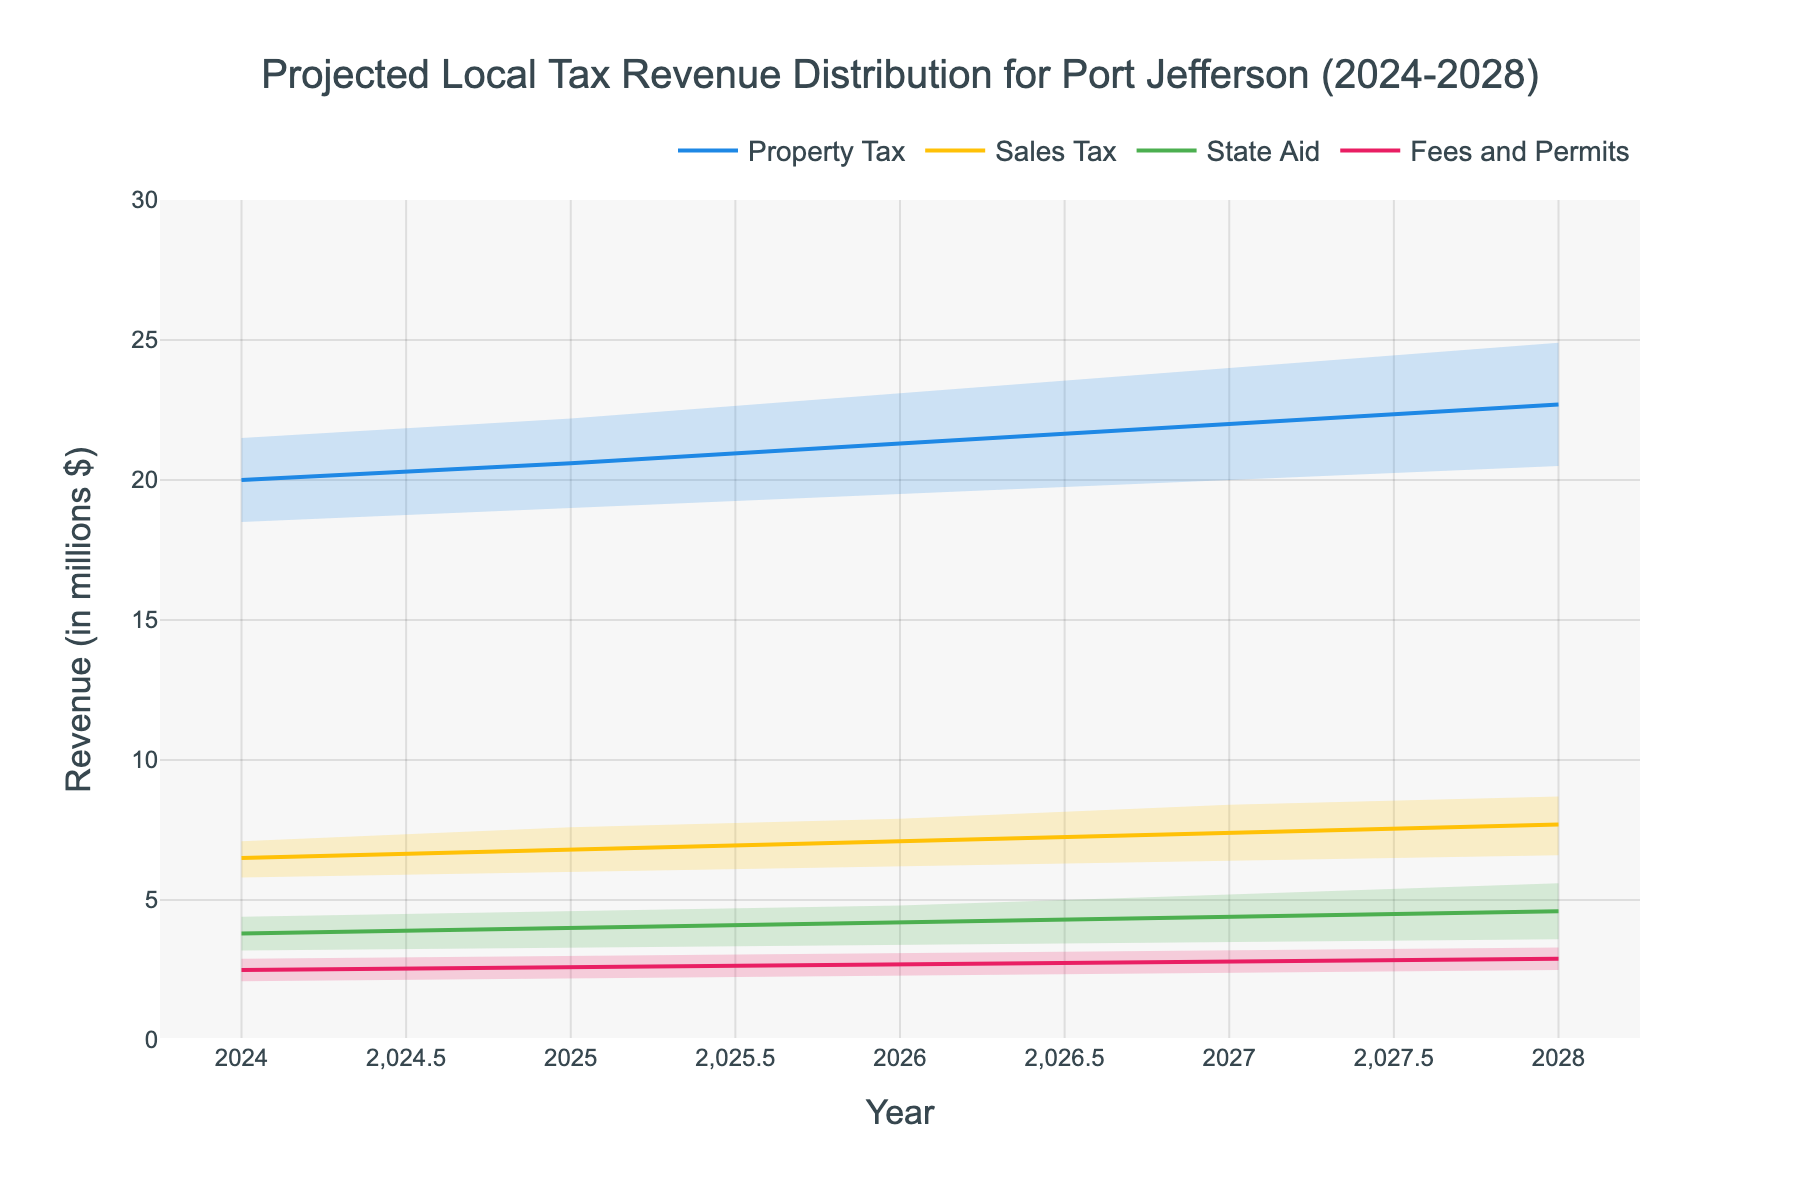What's the title of the figure? Look at the top-center of the figure for the title text.
Answer: Projected Local Tax Revenue Distribution for Port Jefferson (2024-2028) What is the projected range of Property Tax revenue in 2026? Check the bands related to Property Tax for the year 2026. The range is between the lowest and highest values.
Answer: $19.5M - $23.1M Which revenue category shows the highest mid-value projection in 2028? Compare the mid-value projections for all categories in 2028.
Answer: Property Tax Between Sales Tax and State Aid, which category shows a higher high-value projection in 2027? Compare the high-value projections for Sales Tax and State Aid in 2027.
Answer: Sales Tax What is the width of the uncertainty (high - low) for Fees and Permits revenue in 2024? Subtract the low estimate from the high estimate for Fees and Permits in 2024.
Answer: $0.8M What is the average mid-value projection for State Aid over the 5 years? Add the mid-values for State Aid from 2024 to 2028 and divide by 5.
Answer: $4.2M Which category shows the most consistent (least variation) revenue projection from 2024 to 2028? Compare the range (high - low) for each category across the years 2024 to 2028.
Answer: Fees and Permits What is the trend of the mid-value projections for Sales Tax from 2024 to 2028? Observe the mid-value projections for Sales Tax from 2024 to 2028 to determine whether they are increasing, decreasing, or remaining constant.
Answer: Increasing Do any categories show overlapping high-value projections with the mid-value projections of other categories in 2026? Identify if the high values of any category overlap with the mid-values of different categories in 2026.
Answer: No 